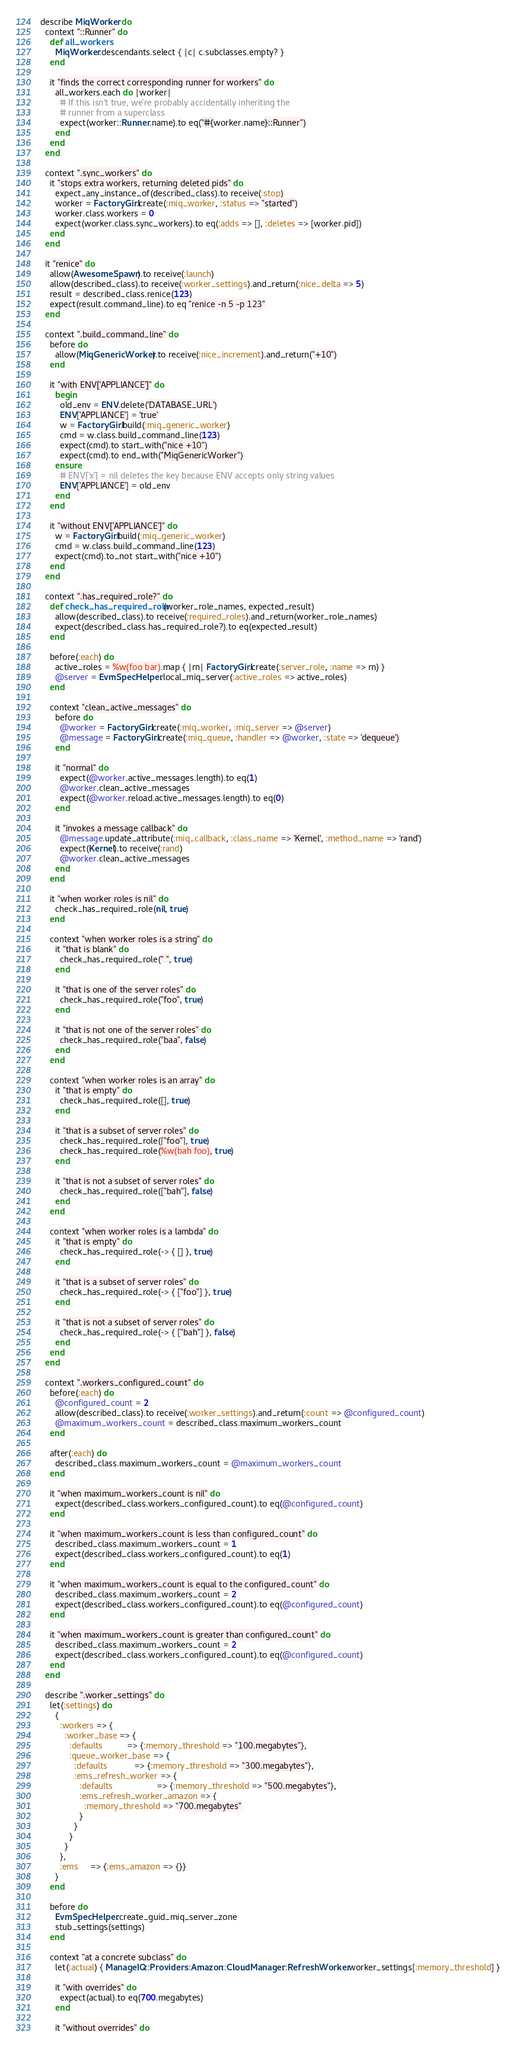Convert code to text. <code><loc_0><loc_0><loc_500><loc_500><_Ruby_>describe MiqWorker do
  context "::Runner" do
    def all_workers
      MiqWorker.descendants.select { |c| c.subclasses.empty? }
    end

    it "finds the correct corresponding runner for workers" do
      all_workers.each do |worker|
        # If this isn't true, we're probably accidentally inheriting the
        # runner from a superclass
        expect(worker::Runner.name).to eq("#{worker.name}::Runner")
      end
    end
  end

  context ".sync_workers" do
    it "stops extra workers, returning deleted pids" do
      expect_any_instance_of(described_class).to receive(:stop)
      worker = FactoryGirl.create(:miq_worker, :status => "started")
      worker.class.workers = 0
      expect(worker.class.sync_workers).to eq(:adds => [], :deletes => [worker.pid])
    end
  end

  it "renice" do
    allow(AwesomeSpawn).to receive(:launch)
    allow(described_class).to receive(:worker_settings).and_return(:nice_delta => 5)
    result = described_class.renice(123)
    expect(result.command_line).to eq "renice -n 5 -p 123"
  end

  context ".build_command_line" do
    before do
      allow(MiqGenericWorker).to receive(:nice_increment).and_return("+10")
    end

    it "with ENV['APPLIANCE']" do
      begin
        old_env = ENV.delete('DATABASE_URL')
        ENV['APPLIANCE'] = 'true'
        w = FactoryGirl.build(:miq_generic_worker)
        cmd = w.class.build_command_line(123)
        expect(cmd).to start_with("nice +10")
        expect(cmd).to end_with("MiqGenericWorker")
      ensure
        # ENV['x'] = nil deletes the key because ENV accepts only string values
        ENV['APPLIANCE'] = old_env
      end
    end

    it "without ENV['APPLIANCE']" do
      w = FactoryGirl.build(:miq_generic_worker)
      cmd = w.class.build_command_line(123)
      expect(cmd).to_not start_with("nice +10")
    end
  end

  context ".has_required_role?" do
    def check_has_required_role(worker_role_names, expected_result)
      allow(described_class).to receive(:required_roles).and_return(worker_role_names)
      expect(described_class.has_required_role?).to eq(expected_result)
    end

    before(:each) do
      active_roles = %w(foo bar).map { |rn| FactoryGirl.create(:server_role, :name => rn) }
      @server = EvmSpecHelper.local_miq_server(:active_roles => active_roles)
    end

    context "clean_active_messages" do
      before do
        @worker = FactoryGirl.create(:miq_worker, :miq_server => @server)
        @message = FactoryGirl.create(:miq_queue, :handler => @worker, :state => 'dequeue')
      end

      it "normal" do
        expect(@worker.active_messages.length).to eq(1)
        @worker.clean_active_messages
        expect(@worker.reload.active_messages.length).to eq(0)
      end

      it "invokes a message callback" do
        @message.update_attribute(:miq_callback, :class_name => 'Kernel', :method_name => 'rand')
        expect(Kernel).to receive(:rand)
        @worker.clean_active_messages
      end
    end

    it "when worker roles is nil" do
      check_has_required_role(nil, true)
    end

    context "when worker roles is a string" do
      it "that is blank" do
        check_has_required_role(" ", true)
      end

      it "that is one of the server roles" do
        check_has_required_role("foo", true)
      end

      it "that is not one of the server roles" do
        check_has_required_role("baa", false)
      end
    end

    context "when worker roles is an array" do
      it "that is empty" do
        check_has_required_role([], true)
      end

      it "that is a subset of server roles" do
        check_has_required_role(["foo"], true)
        check_has_required_role(%w(bah foo), true)
      end

      it "that is not a subset of server roles" do
        check_has_required_role(["bah"], false)
      end
    end

    context "when worker roles is a lambda" do
      it "that is empty" do
        check_has_required_role(-> { [] }, true)
      end

      it "that is a subset of server roles" do
        check_has_required_role(-> { ["foo"] }, true)
      end

      it "that is not a subset of server roles" do
        check_has_required_role(-> { ["bah"] }, false)
      end
    end
  end

  context ".workers_configured_count" do
    before(:each) do
      @configured_count = 2
      allow(described_class).to receive(:worker_settings).and_return(:count => @configured_count)
      @maximum_workers_count = described_class.maximum_workers_count
    end

    after(:each) do
      described_class.maximum_workers_count = @maximum_workers_count
    end

    it "when maximum_workers_count is nil" do
      expect(described_class.workers_configured_count).to eq(@configured_count)
    end

    it "when maximum_workers_count is less than configured_count" do
      described_class.maximum_workers_count = 1
      expect(described_class.workers_configured_count).to eq(1)
    end

    it "when maximum_workers_count is equal to the configured_count" do
      described_class.maximum_workers_count = 2
      expect(described_class.workers_configured_count).to eq(@configured_count)
    end

    it "when maximum_workers_count is greater than configured_count" do
      described_class.maximum_workers_count = 2
      expect(described_class.workers_configured_count).to eq(@configured_count)
    end
  end

  describe ".worker_settings" do
    let(:settings) do
      {
        :workers => {
          :worker_base => {
            :defaults          => {:memory_threshold => "100.megabytes"},
            :queue_worker_base => {
              :defaults           => {:memory_threshold => "300.megabytes"},
              :ems_refresh_worker => {
                :defaults                  => {:memory_threshold => "500.megabytes"},
                :ems_refresh_worker_amazon => {
                  :memory_threshold => "700.megabytes"
                }
              }
            }
          }
        },
        :ems     => {:ems_amazon => {}}
      }
    end

    before do
      EvmSpecHelper.create_guid_miq_server_zone
      stub_settings(settings)
    end

    context "at a concrete subclass" do
      let(:actual) { ManageIQ::Providers::Amazon::CloudManager::RefreshWorker.worker_settings[:memory_threshold] }

      it "with overrides" do
        expect(actual).to eq(700.megabytes)
      end

      it "without overrides" do</code> 